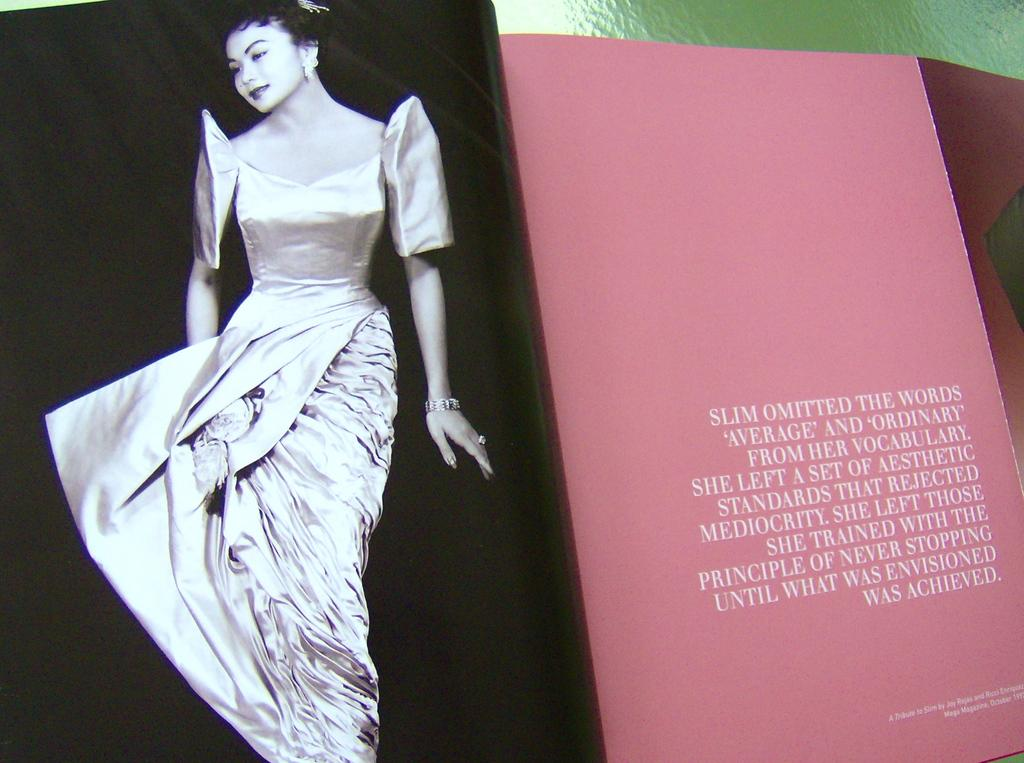<image>
Give a short and clear explanation of the subsequent image. A magazine with a picture of a woman says "Slim omitted the words average and ordinary" 